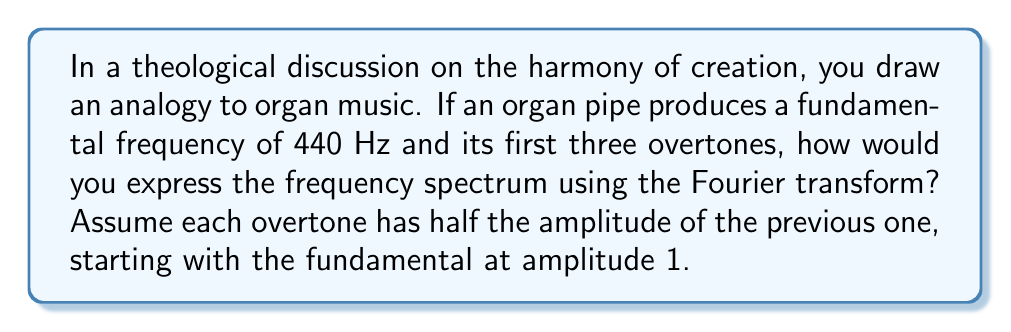Teach me how to tackle this problem. To approach this problem, let's break it down into steps:

1) First, let's identify the frequencies present in the signal:
   - Fundamental: 440 Hz
   - First overtone: 880 Hz (2 * 440)
   - Second overtone: 1320 Hz (3 * 440)
   - Third overtone: 1760 Hz (4 * 440)

2) Now, let's consider the amplitudes:
   - Fundamental: 1
   - First overtone: 1/2
   - Second overtone: 1/4
   - Third overtone: 1/8

3) In the time domain, our signal can be represented as:

   $$x(t) = \sin(2\pi \cdot 440t) + \frac{1}{2}\sin(2\pi \cdot 880t) + \frac{1}{4}\sin(2\pi \cdot 1320t) + \frac{1}{8}\sin(2\pi \cdot 1760t)$$

4) The Fourier transform of a sine wave with frequency $f$ and amplitude $A$ is given by:

   $$\mathcal{F}\{A\sin(2\pi ft)\} = \frac{A}{2i}[\delta(f) - \delta(-f)]$$

   Where $\delta(f)$ is the Dirac delta function.

5) Applying this to each component of our signal:

   $$\mathcal{F}\{x(t)\} = \frac{1}{2i}[\delta(f-440) - \delta(f+440)] + \frac{1/4}{2i}[\delta(f-880) - \delta(f+880)] $$
   $$ + \frac{1/8}{2i}[\delta(f-1320) - \delta(f+1320)] + \frac{1/16}{2i}[\delta(f-1760) - \delta(f+1760)]$$

6) This can be simplified to:

   $$\mathcal{F}\{x(t)\} = \frac{1}{2i}[\delta(f-440) - \delta(f+440)] + \frac{1}{8i}[\delta(f-880) - \delta(f+880)]$$
   $$ + \frac{1}{16i}[\delta(f-1320) - \delta(f+1320)] + \frac{1}{32i}[\delta(f-1760) - \delta(f+1760)]$$

This expression represents the frequency spectrum of the organ pipe sound in the Fourier domain.
Answer: $$\mathcal{F}\{x(t)\} = \frac{1}{2i}[\delta(f-440) - \delta(f+440)] + \frac{1}{8i}[\delta(f-880) - \delta(f+880)] + \frac{1}{16i}[\delta(f-1320) - \delta(f+1320)] + \frac{1}{32i}[\delta(f-1760) - \delta(f+1760)]$$ 